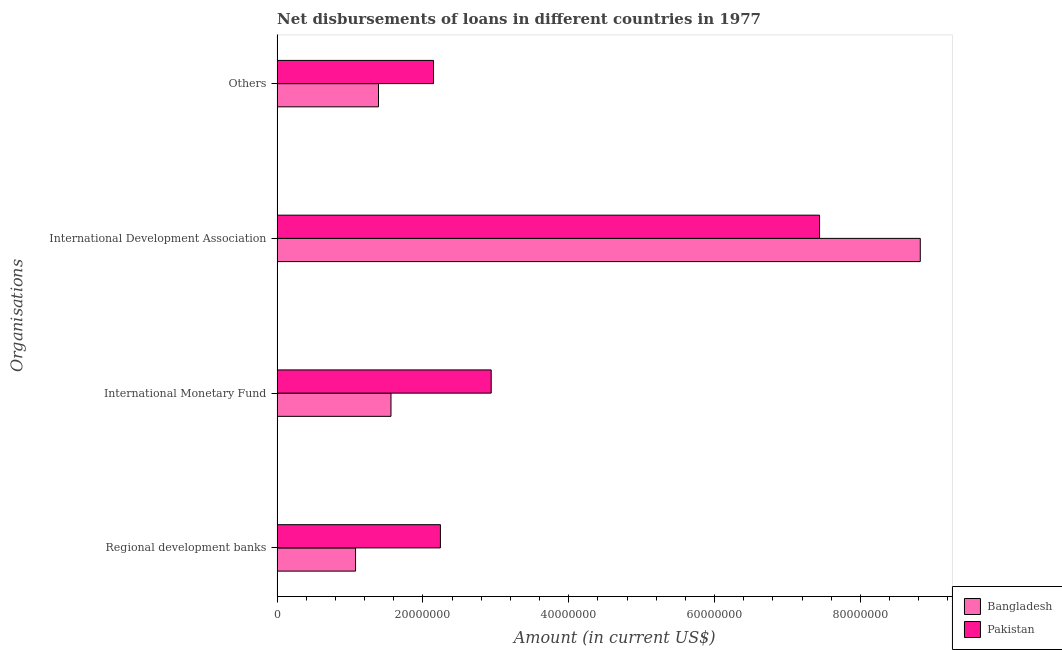How many different coloured bars are there?
Provide a succinct answer. 2. How many groups of bars are there?
Provide a succinct answer. 4. Are the number of bars on each tick of the Y-axis equal?
Offer a terse response. Yes. How many bars are there on the 4th tick from the bottom?
Make the answer very short. 2. What is the label of the 3rd group of bars from the top?
Your answer should be compact. International Monetary Fund. What is the amount of loan disimbursed by other organisations in Bangladesh?
Provide a short and direct response. 1.39e+07. Across all countries, what is the maximum amount of loan disimbursed by regional development banks?
Offer a very short reply. 2.24e+07. Across all countries, what is the minimum amount of loan disimbursed by international development association?
Offer a terse response. 7.44e+07. In which country was the amount of loan disimbursed by other organisations maximum?
Make the answer very short. Pakistan. In which country was the amount of loan disimbursed by regional development banks minimum?
Provide a succinct answer. Bangladesh. What is the total amount of loan disimbursed by international monetary fund in the graph?
Your answer should be very brief. 4.50e+07. What is the difference between the amount of loan disimbursed by regional development banks in Bangladesh and that in Pakistan?
Offer a terse response. -1.16e+07. What is the difference between the amount of loan disimbursed by other organisations in Pakistan and the amount of loan disimbursed by international monetary fund in Bangladesh?
Your response must be concise. 5.83e+06. What is the average amount of loan disimbursed by regional development banks per country?
Your answer should be very brief. 1.66e+07. What is the difference between the amount of loan disimbursed by international development association and amount of loan disimbursed by regional development banks in Pakistan?
Offer a very short reply. 5.20e+07. In how many countries, is the amount of loan disimbursed by regional development banks greater than 32000000 US$?
Ensure brevity in your answer.  0. What is the ratio of the amount of loan disimbursed by other organisations in Bangladesh to that in Pakistan?
Your answer should be compact. 0.65. Is the difference between the amount of loan disimbursed by other organisations in Pakistan and Bangladesh greater than the difference between the amount of loan disimbursed by regional development banks in Pakistan and Bangladesh?
Your answer should be compact. No. What is the difference between the highest and the second highest amount of loan disimbursed by other organisations?
Offer a very short reply. 7.55e+06. What is the difference between the highest and the lowest amount of loan disimbursed by regional development banks?
Your response must be concise. 1.16e+07. In how many countries, is the amount of loan disimbursed by other organisations greater than the average amount of loan disimbursed by other organisations taken over all countries?
Ensure brevity in your answer.  1. Is it the case that in every country, the sum of the amount of loan disimbursed by other organisations and amount of loan disimbursed by international monetary fund is greater than the sum of amount of loan disimbursed by regional development banks and amount of loan disimbursed by international development association?
Keep it short and to the point. No. What does the 1st bar from the bottom in Others represents?
Give a very brief answer. Bangladesh. Is it the case that in every country, the sum of the amount of loan disimbursed by regional development banks and amount of loan disimbursed by international monetary fund is greater than the amount of loan disimbursed by international development association?
Offer a very short reply. No. How many countries are there in the graph?
Provide a succinct answer. 2. Are the values on the major ticks of X-axis written in scientific E-notation?
Provide a succinct answer. No. Does the graph contain any zero values?
Keep it short and to the point. No. Does the graph contain grids?
Keep it short and to the point. No. How many legend labels are there?
Ensure brevity in your answer.  2. How are the legend labels stacked?
Provide a short and direct response. Vertical. What is the title of the graph?
Offer a very short reply. Net disbursements of loans in different countries in 1977. What is the label or title of the Y-axis?
Keep it short and to the point. Organisations. What is the Amount (in current US$) of Bangladesh in Regional development banks?
Provide a short and direct response. 1.08e+07. What is the Amount (in current US$) in Pakistan in Regional development banks?
Offer a very short reply. 2.24e+07. What is the Amount (in current US$) of Bangladesh in International Monetary Fund?
Ensure brevity in your answer.  1.56e+07. What is the Amount (in current US$) of Pakistan in International Monetary Fund?
Offer a very short reply. 2.94e+07. What is the Amount (in current US$) of Bangladesh in International Development Association?
Your answer should be compact. 8.82e+07. What is the Amount (in current US$) of Pakistan in International Development Association?
Your answer should be compact. 7.44e+07. What is the Amount (in current US$) in Bangladesh in Others?
Provide a short and direct response. 1.39e+07. What is the Amount (in current US$) in Pakistan in Others?
Provide a succinct answer. 2.14e+07. Across all Organisations, what is the maximum Amount (in current US$) of Bangladesh?
Make the answer very short. 8.82e+07. Across all Organisations, what is the maximum Amount (in current US$) of Pakistan?
Provide a short and direct response. 7.44e+07. Across all Organisations, what is the minimum Amount (in current US$) of Bangladesh?
Provide a short and direct response. 1.08e+07. Across all Organisations, what is the minimum Amount (in current US$) in Pakistan?
Keep it short and to the point. 2.14e+07. What is the total Amount (in current US$) in Bangladesh in the graph?
Provide a succinct answer. 1.28e+08. What is the total Amount (in current US$) of Pakistan in the graph?
Provide a succinct answer. 1.48e+08. What is the difference between the Amount (in current US$) in Bangladesh in Regional development banks and that in International Monetary Fund?
Make the answer very short. -4.86e+06. What is the difference between the Amount (in current US$) of Pakistan in Regional development banks and that in International Monetary Fund?
Offer a terse response. -6.96e+06. What is the difference between the Amount (in current US$) in Bangladesh in Regional development banks and that in International Development Association?
Ensure brevity in your answer.  -7.75e+07. What is the difference between the Amount (in current US$) of Pakistan in Regional development banks and that in International Development Association?
Provide a short and direct response. -5.20e+07. What is the difference between the Amount (in current US$) in Bangladesh in Regional development banks and that in Others?
Offer a terse response. -3.14e+06. What is the difference between the Amount (in current US$) in Pakistan in Regional development banks and that in Others?
Keep it short and to the point. 9.45e+05. What is the difference between the Amount (in current US$) of Bangladesh in International Monetary Fund and that in International Development Association?
Make the answer very short. -7.26e+07. What is the difference between the Amount (in current US$) in Pakistan in International Monetary Fund and that in International Development Association?
Keep it short and to the point. -4.50e+07. What is the difference between the Amount (in current US$) in Bangladesh in International Monetary Fund and that in Others?
Offer a very short reply. 1.72e+06. What is the difference between the Amount (in current US$) of Pakistan in International Monetary Fund and that in Others?
Provide a short and direct response. 7.91e+06. What is the difference between the Amount (in current US$) of Bangladesh in International Development Association and that in Others?
Your answer should be very brief. 7.43e+07. What is the difference between the Amount (in current US$) in Pakistan in International Development Association and that in Others?
Keep it short and to the point. 5.29e+07. What is the difference between the Amount (in current US$) of Bangladesh in Regional development banks and the Amount (in current US$) of Pakistan in International Monetary Fund?
Offer a terse response. -1.86e+07. What is the difference between the Amount (in current US$) of Bangladesh in Regional development banks and the Amount (in current US$) of Pakistan in International Development Association?
Your answer should be compact. -6.36e+07. What is the difference between the Amount (in current US$) of Bangladesh in Regional development banks and the Amount (in current US$) of Pakistan in Others?
Keep it short and to the point. -1.07e+07. What is the difference between the Amount (in current US$) of Bangladesh in International Monetary Fund and the Amount (in current US$) of Pakistan in International Development Association?
Provide a short and direct response. -5.88e+07. What is the difference between the Amount (in current US$) of Bangladesh in International Monetary Fund and the Amount (in current US$) of Pakistan in Others?
Keep it short and to the point. -5.83e+06. What is the difference between the Amount (in current US$) in Bangladesh in International Development Association and the Amount (in current US$) in Pakistan in Others?
Provide a succinct answer. 6.68e+07. What is the average Amount (in current US$) of Bangladesh per Organisations?
Keep it short and to the point. 3.21e+07. What is the average Amount (in current US$) in Pakistan per Organisations?
Offer a terse response. 3.69e+07. What is the difference between the Amount (in current US$) in Bangladesh and Amount (in current US$) in Pakistan in Regional development banks?
Offer a terse response. -1.16e+07. What is the difference between the Amount (in current US$) of Bangladesh and Amount (in current US$) of Pakistan in International Monetary Fund?
Keep it short and to the point. -1.37e+07. What is the difference between the Amount (in current US$) in Bangladesh and Amount (in current US$) in Pakistan in International Development Association?
Ensure brevity in your answer.  1.38e+07. What is the difference between the Amount (in current US$) in Bangladesh and Amount (in current US$) in Pakistan in Others?
Provide a succinct answer. -7.55e+06. What is the ratio of the Amount (in current US$) in Bangladesh in Regional development banks to that in International Monetary Fund?
Provide a short and direct response. 0.69. What is the ratio of the Amount (in current US$) of Pakistan in Regional development banks to that in International Monetary Fund?
Ensure brevity in your answer.  0.76. What is the ratio of the Amount (in current US$) in Bangladesh in Regional development banks to that in International Development Association?
Your answer should be very brief. 0.12. What is the ratio of the Amount (in current US$) in Pakistan in Regional development banks to that in International Development Association?
Give a very brief answer. 0.3. What is the ratio of the Amount (in current US$) of Bangladesh in Regional development banks to that in Others?
Provide a succinct answer. 0.77. What is the ratio of the Amount (in current US$) of Pakistan in Regional development banks to that in Others?
Give a very brief answer. 1.04. What is the ratio of the Amount (in current US$) in Bangladesh in International Monetary Fund to that in International Development Association?
Your answer should be very brief. 0.18. What is the ratio of the Amount (in current US$) of Pakistan in International Monetary Fund to that in International Development Association?
Your answer should be very brief. 0.39. What is the ratio of the Amount (in current US$) of Bangladesh in International Monetary Fund to that in Others?
Keep it short and to the point. 1.12. What is the ratio of the Amount (in current US$) of Pakistan in International Monetary Fund to that in Others?
Offer a very short reply. 1.37. What is the ratio of the Amount (in current US$) in Bangladesh in International Development Association to that in Others?
Offer a very short reply. 6.35. What is the ratio of the Amount (in current US$) of Pakistan in International Development Association to that in Others?
Your answer should be compact. 3.47. What is the difference between the highest and the second highest Amount (in current US$) of Bangladesh?
Your answer should be compact. 7.26e+07. What is the difference between the highest and the second highest Amount (in current US$) in Pakistan?
Provide a succinct answer. 4.50e+07. What is the difference between the highest and the lowest Amount (in current US$) of Bangladesh?
Your answer should be very brief. 7.75e+07. What is the difference between the highest and the lowest Amount (in current US$) of Pakistan?
Give a very brief answer. 5.29e+07. 